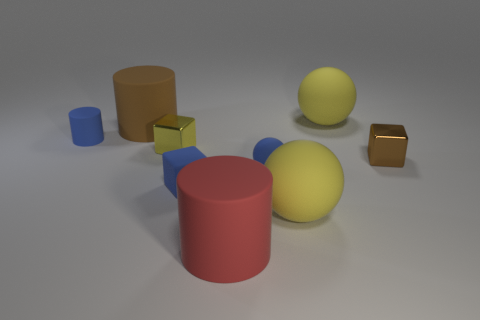Subtract all balls. How many objects are left? 6 Add 9 tiny purple rubber things. How many tiny purple rubber things exist? 9 Subtract 0 cyan cubes. How many objects are left? 9 Subtract all big matte things. Subtract all cubes. How many objects are left? 2 Add 8 small cylinders. How many small cylinders are left? 9 